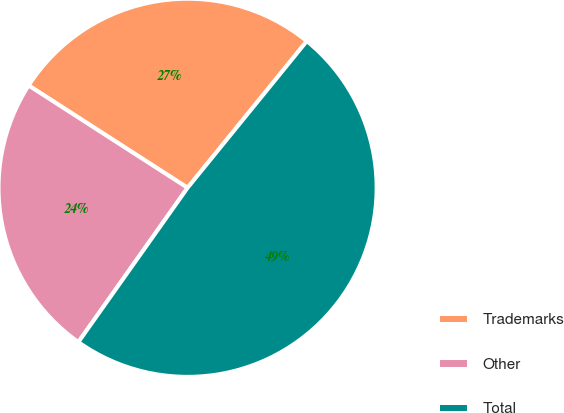Convert chart. <chart><loc_0><loc_0><loc_500><loc_500><pie_chart><fcel>Trademarks<fcel>Other<fcel>Total<nl><fcel>26.76%<fcel>24.3%<fcel>48.94%<nl></chart> 